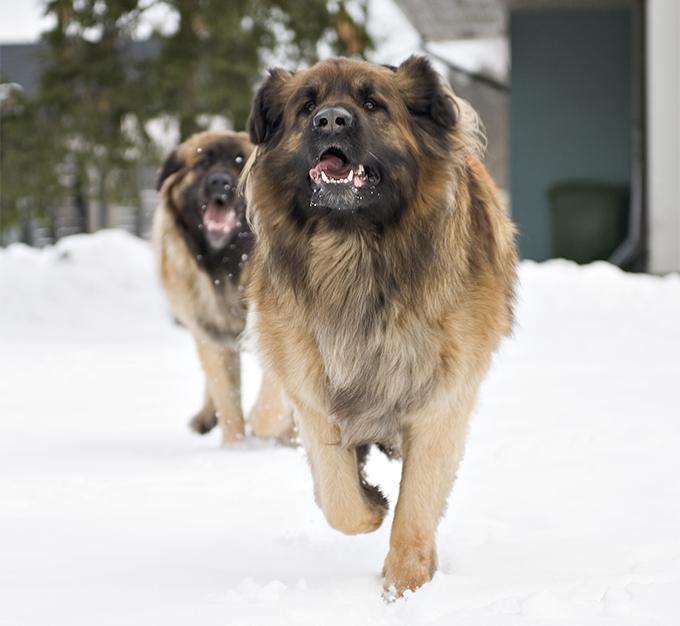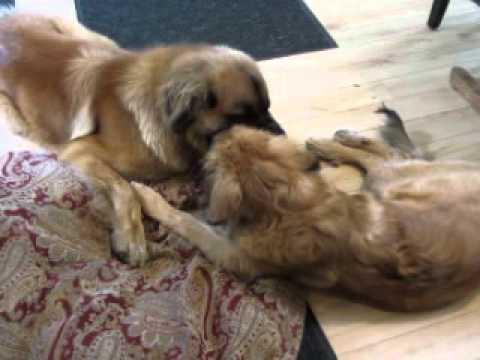The first image is the image on the left, the second image is the image on the right. Analyze the images presented: Is the assertion "The right image has exactly two dogs." valid? Answer yes or no. Yes. The first image is the image on the left, the second image is the image on the right. Considering the images on both sides, is "In one of the images, one dog is predominantly white, while the other is predominantly brown." valid? Answer yes or no. No. 